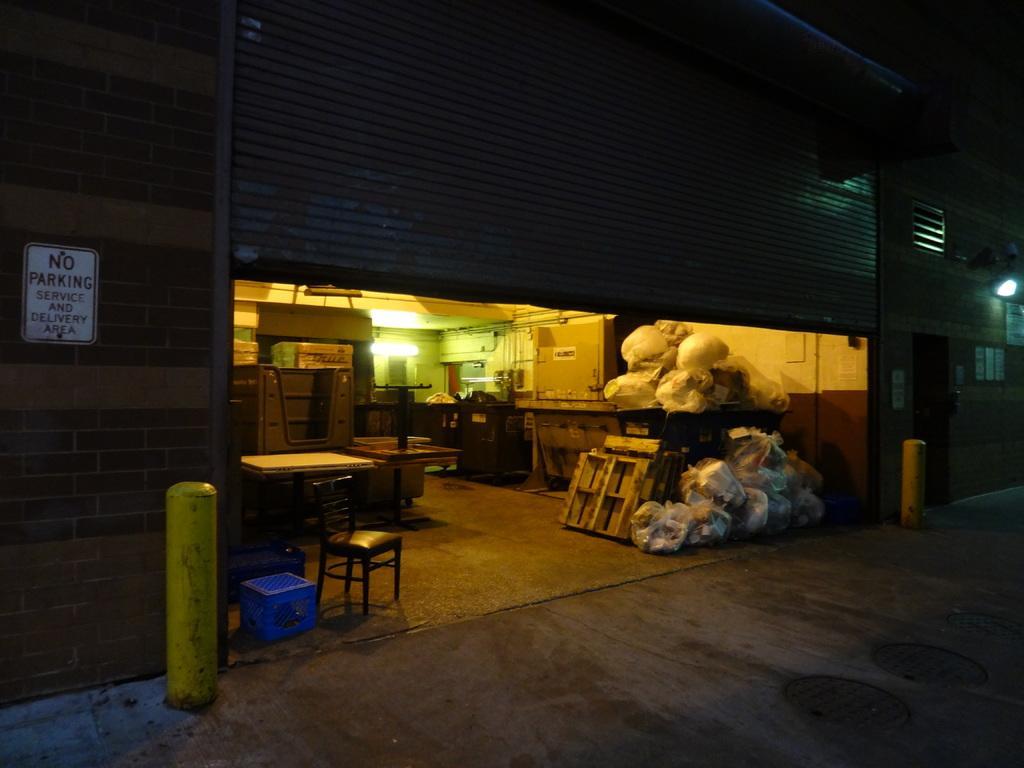Please provide a concise description of this image. In this picture, there is a building with a roller shutter. In the shutter, there are plastic bags placed on the table. Towards the left, there is a table, chair and a carton box. In the center, there is a light. Towards the left corner, there is a board with some text. 